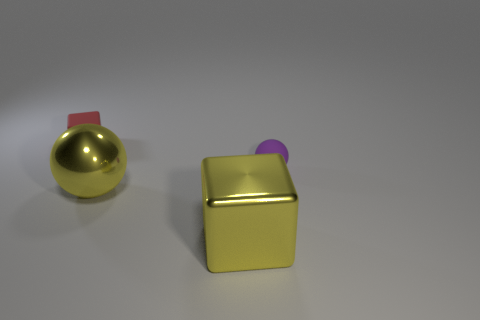Does the large shiny block have the same color as the metal sphere?
Offer a terse response. Yes. What shape is the object that is the same color as the big shiny block?
Your answer should be compact. Sphere. Is the material of the purple ball in front of the tiny red thing the same as the block that is behind the purple rubber sphere?
Make the answer very short. Yes. There is a tiny red thing behind the large yellow metallic object to the right of the big shiny ball; what number of blocks are behind it?
Offer a terse response. 0. There is a tiny rubber object that is on the left side of the large yellow metallic sphere; does it have the same color as the big metallic object left of the metal block?
Make the answer very short. No. Are there any other things of the same color as the large shiny sphere?
Your answer should be compact. Yes. There is a ball left of the rubber thing on the right side of the big yellow metallic sphere; what color is it?
Your answer should be compact. Yellow. Are there any large red matte things?
Your answer should be compact. No. The thing that is both behind the metal ball and in front of the red object is what color?
Provide a succinct answer. Purple. Is the size of the cube that is behind the yellow cube the same as the sphere that is left of the purple matte sphere?
Provide a short and direct response. No. 